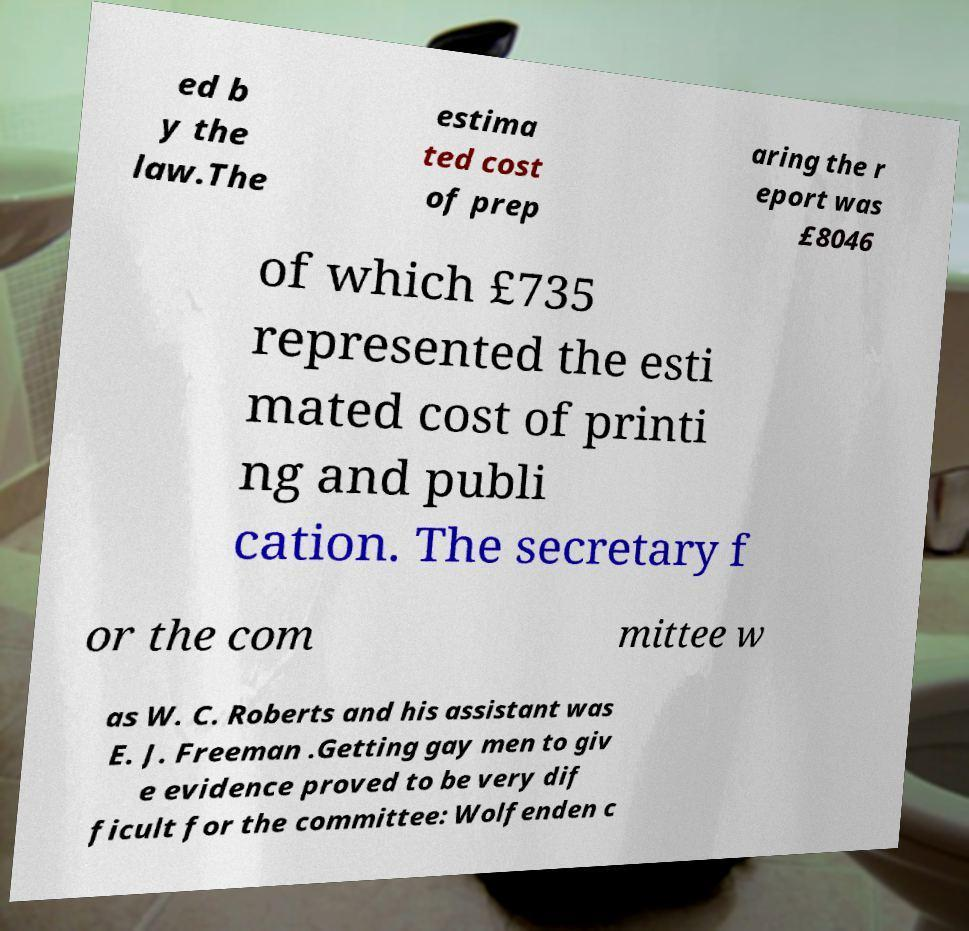Could you extract and type out the text from this image? ed b y the law.The estima ted cost of prep aring the r eport was £8046 of which £735 represented the esti mated cost of printi ng and publi cation. The secretary f or the com mittee w as W. C. Roberts and his assistant was E. J. Freeman .Getting gay men to giv e evidence proved to be very dif ficult for the committee: Wolfenden c 